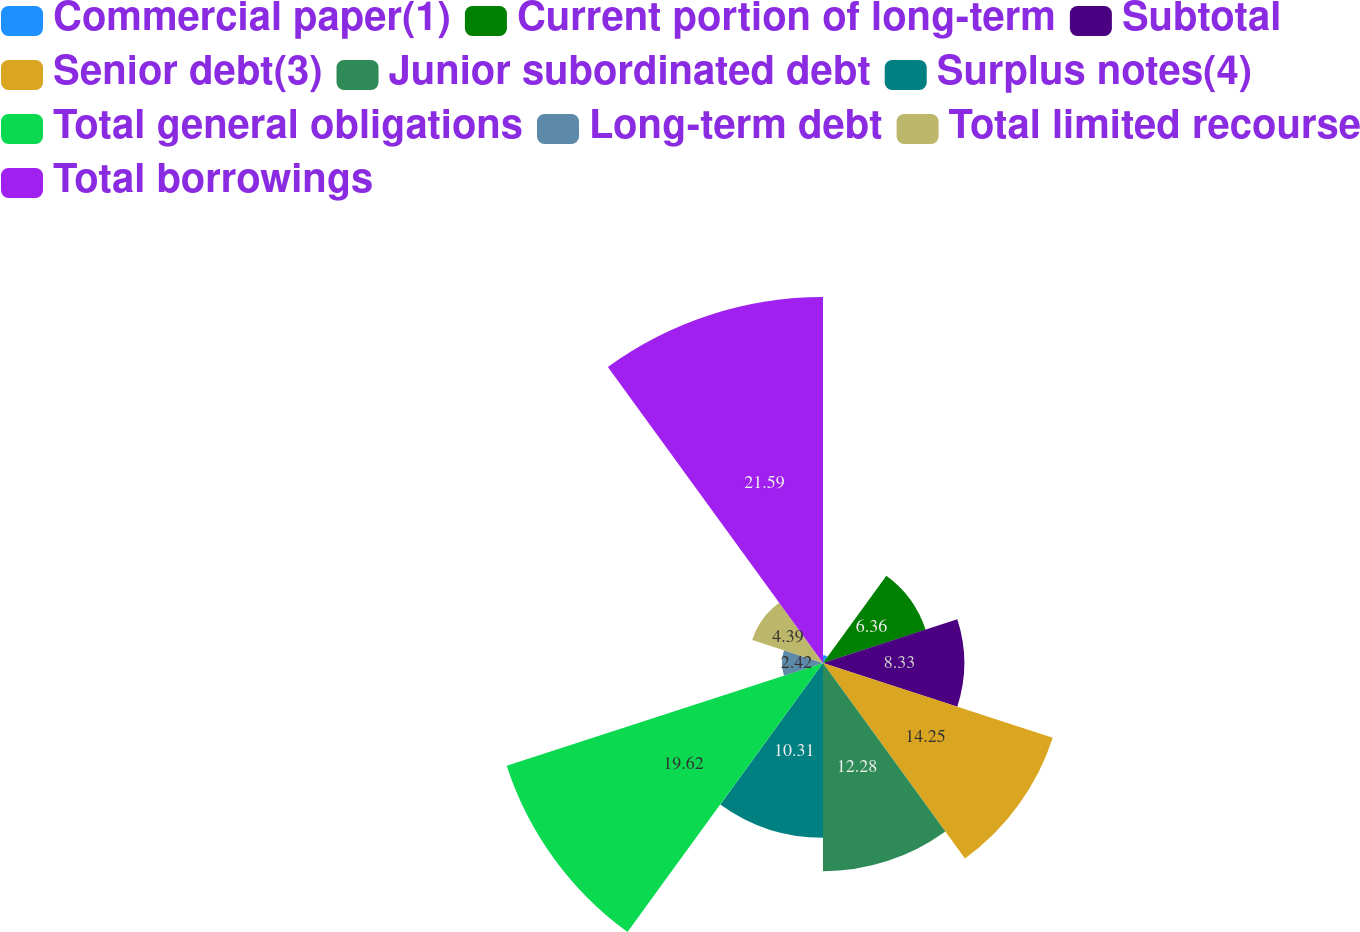Convert chart. <chart><loc_0><loc_0><loc_500><loc_500><pie_chart><fcel>Commercial paper(1)<fcel>Current portion of long-term<fcel>Subtotal<fcel>Senior debt(3)<fcel>Junior subordinated debt<fcel>Surplus notes(4)<fcel>Total general obligations<fcel>Long-term debt<fcel>Total limited recourse<fcel>Total borrowings<nl><fcel>0.45%<fcel>6.36%<fcel>8.33%<fcel>14.25%<fcel>12.28%<fcel>10.31%<fcel>19.62%<fcel>2.42%<fcel>4.39%<fcel>21.59%<nl></chart> 